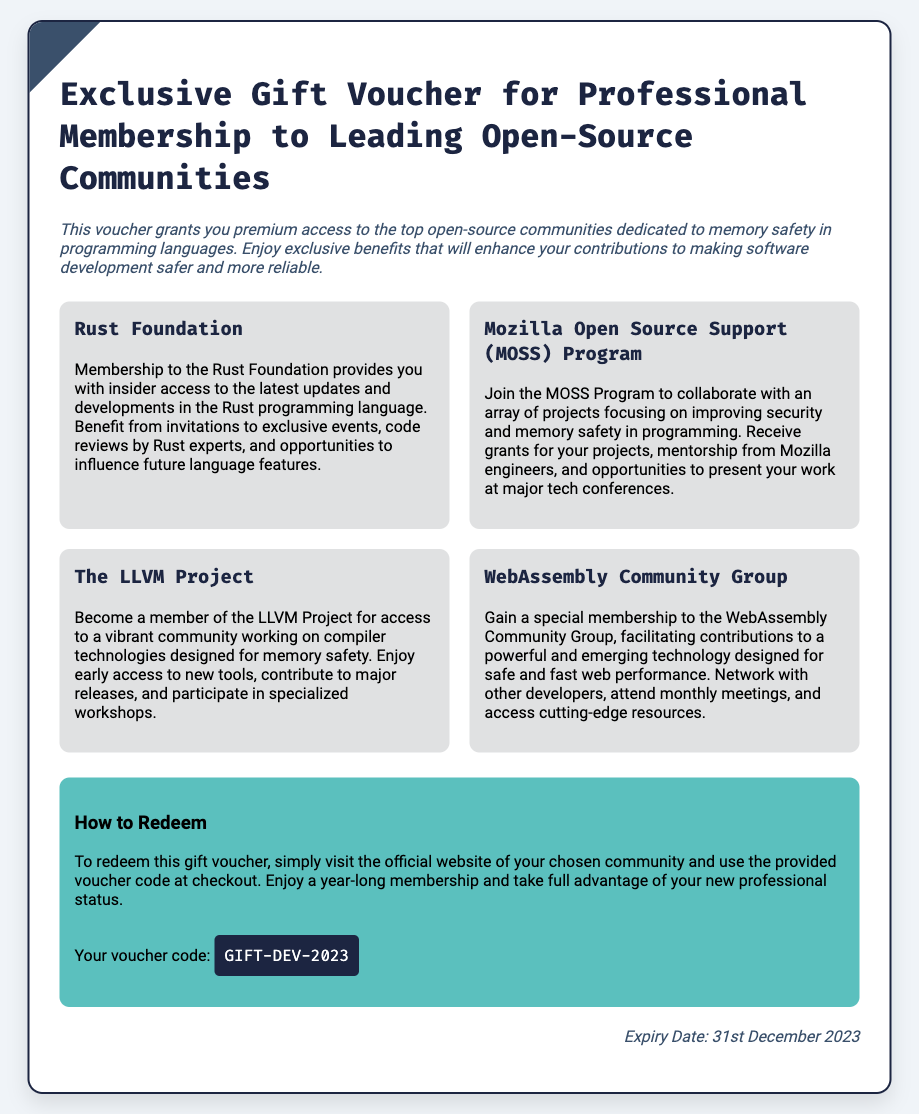What is the title of the voucher? The title is prominently displayed at the top of the voucher to indicate its purpose.
Answer: Exclusive Gift Voucher for Professional Membership to Leading Open-Source Communities What are the benefits included in the voucher? The voucher describes several benefits, each associated with different open-source communities, as outlined in the document.
Answer: Rust Foundation, Mozilla Open Source Support (MOSS) Program, The LLVM Project, WebAssembly Community Group What is the voucher code? The code is provided in the redeem section and is necessary for membership redemption.
Answer: GIFT-DEV-2023 What is the expiry date of the voucher? The expiry date is stated clearly at the bottom of the voucher, indicating the timeframe for redemption.
Answer: 31st December 2023 Which community provides mentorship from engineers? The document specifies which program offers mentorship as part of its benefits.
Answer: Mozilla Open Source Support (MOSS) Program What type of access does the LLVM Project membership provide? The type of access related to community activities and technological developments is specified in the document.
Answer: Access to a vibrant community working on compiler technologies designed for memory safety How can one redeem the voucher? The process for redeeming the voucher is explicitly stated in the redeem section of the document.
Answer: Visit the official website of your chosen community and use the provided voucher code at checkout What are some of the activities offered by the WebAssembly Community Group? The activities mentioned in the document reflect the networking and resource access available to members.
Answer: Network with other developers, attend monthly meetings, and access cutting-edge resources 